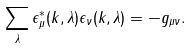Convert formula to latex. <formula><loc_0><loc_0><loc_500><loc_500>\sum _ { \lambda } \epsilon _ { \mu } ^ { * } ( k , \lambda ) \epsilon _ { \nu } ( k , \lambda ) = - g _ { \mu \nu } .</formula> 